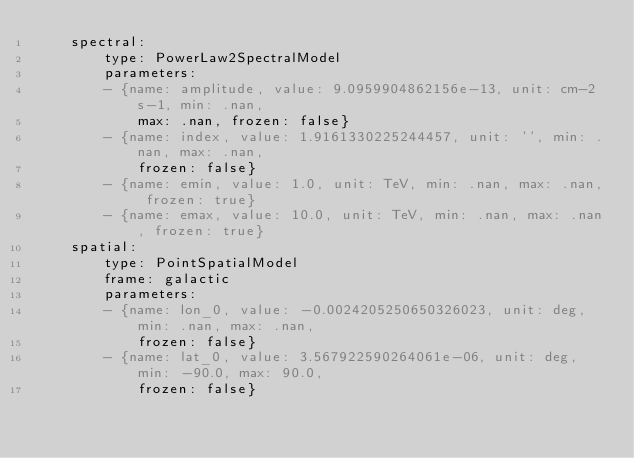Convert code to text. <code><loc_0><loc_0><loc_500><loc_500><_YAML_>    spectral:
        type: PowerLaw2SpectralModel
        parameters:
        - {name: amplitude, value: 9.0959904862156e-13, unit: cm-2 s-1, min: .nan,
            max: .nan, frozen: false}
        - {name: index, value: 1.9161330225244457, unit: '', min: .nan, max: .nan,
            frozen: false}
        - {name: emin, value: 1.0, unit: TeV, min: .nan, max: .nan, frozen: true}
        - {name: emax, value: 10.0, unit: TeV, min: .nan, max: .nan, frozen: true}
    spatial:
        type: PointSpatialModel
        frame: galactic
        parameters:
        - {name: lon_0, value: -0.0024205250650326023, unit: deg, min: .nan, max: .nan,
            frozen: false}
        - {name: lat_0, value: 3.567922590264061e-06, unit: deg, min: -90.0, max: 90.0,
            frozen: false}
</code> 